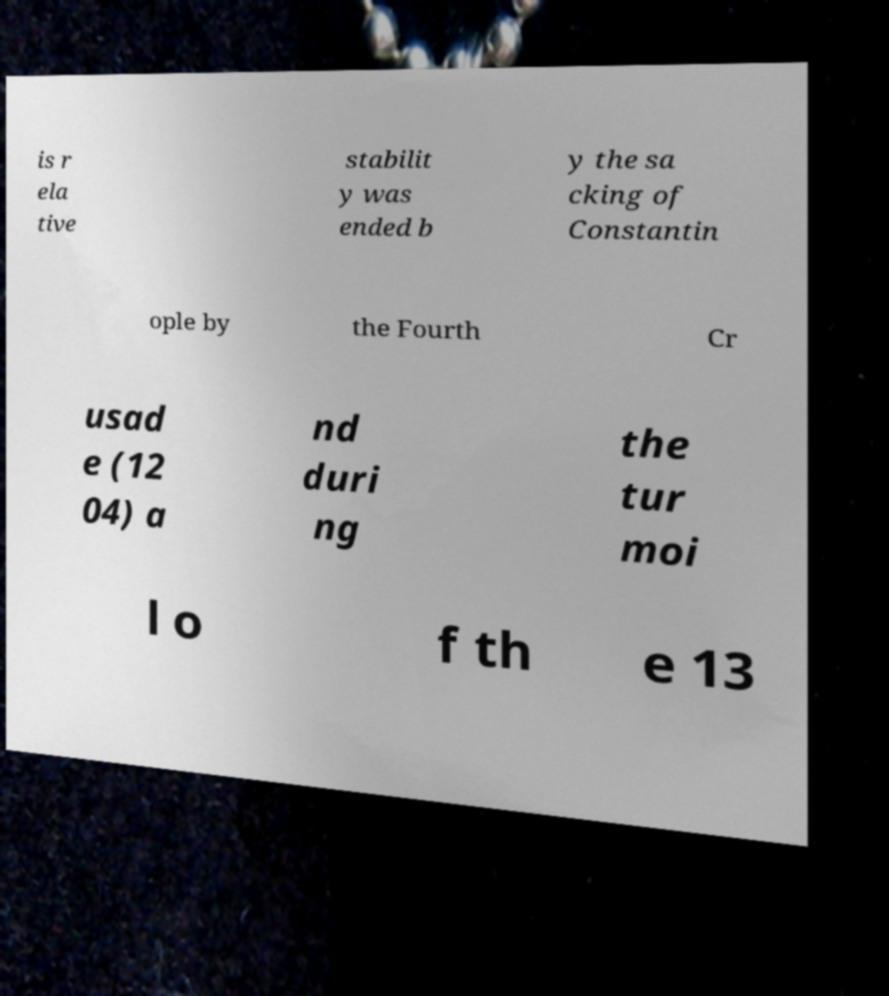Can you read and provide the text displayed in the image?This photo seems to have some interesting text. Can you extract and type it out for me? is r ela tive stabilit y was ended b y the sa cking of Constantin ople by the Fourth Cr usad e (12 04) a nd duri ng the tur moi l o f th e 13 